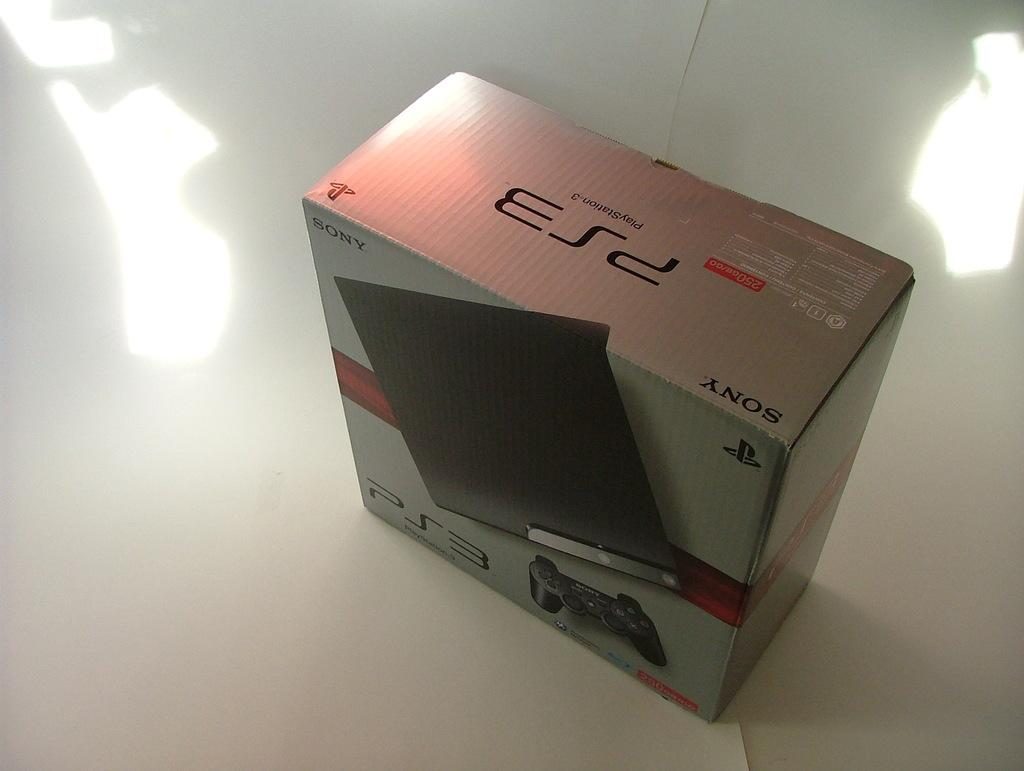<image>
Describe the image concisely. A PS3 box from Sony sits on a white piece of paper. 